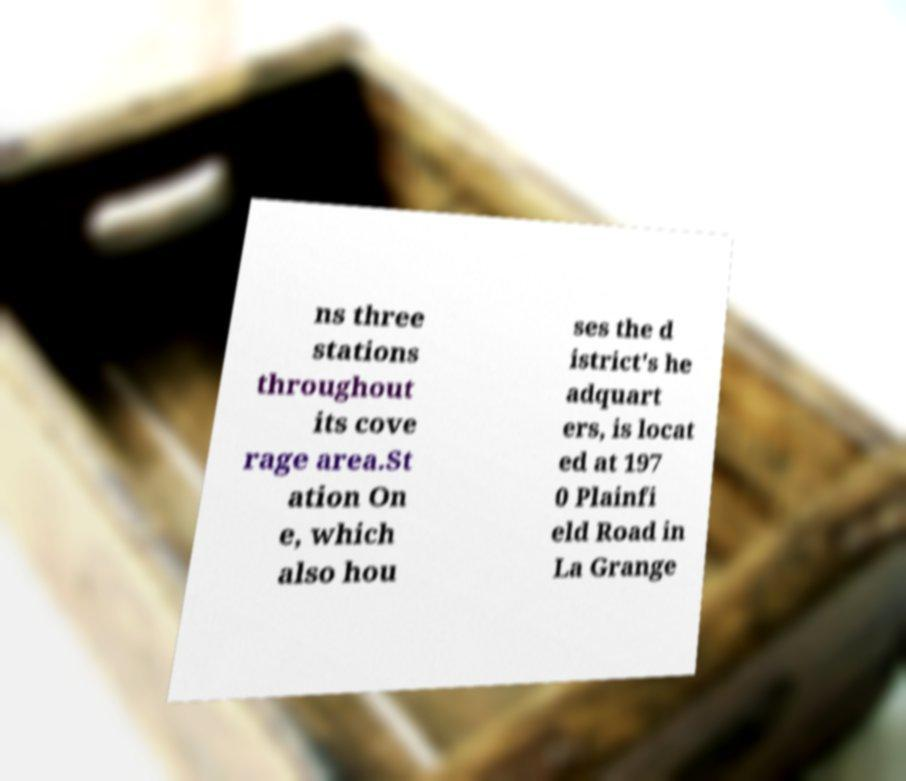Please read and relay the text visible in this image. What does it say? ns three stations throughout its cove rage area.St ation On e, which also hou ses the d istrict's he adquart ers, is locat ed at 197 0 Plainfi eld Road in La Grange 